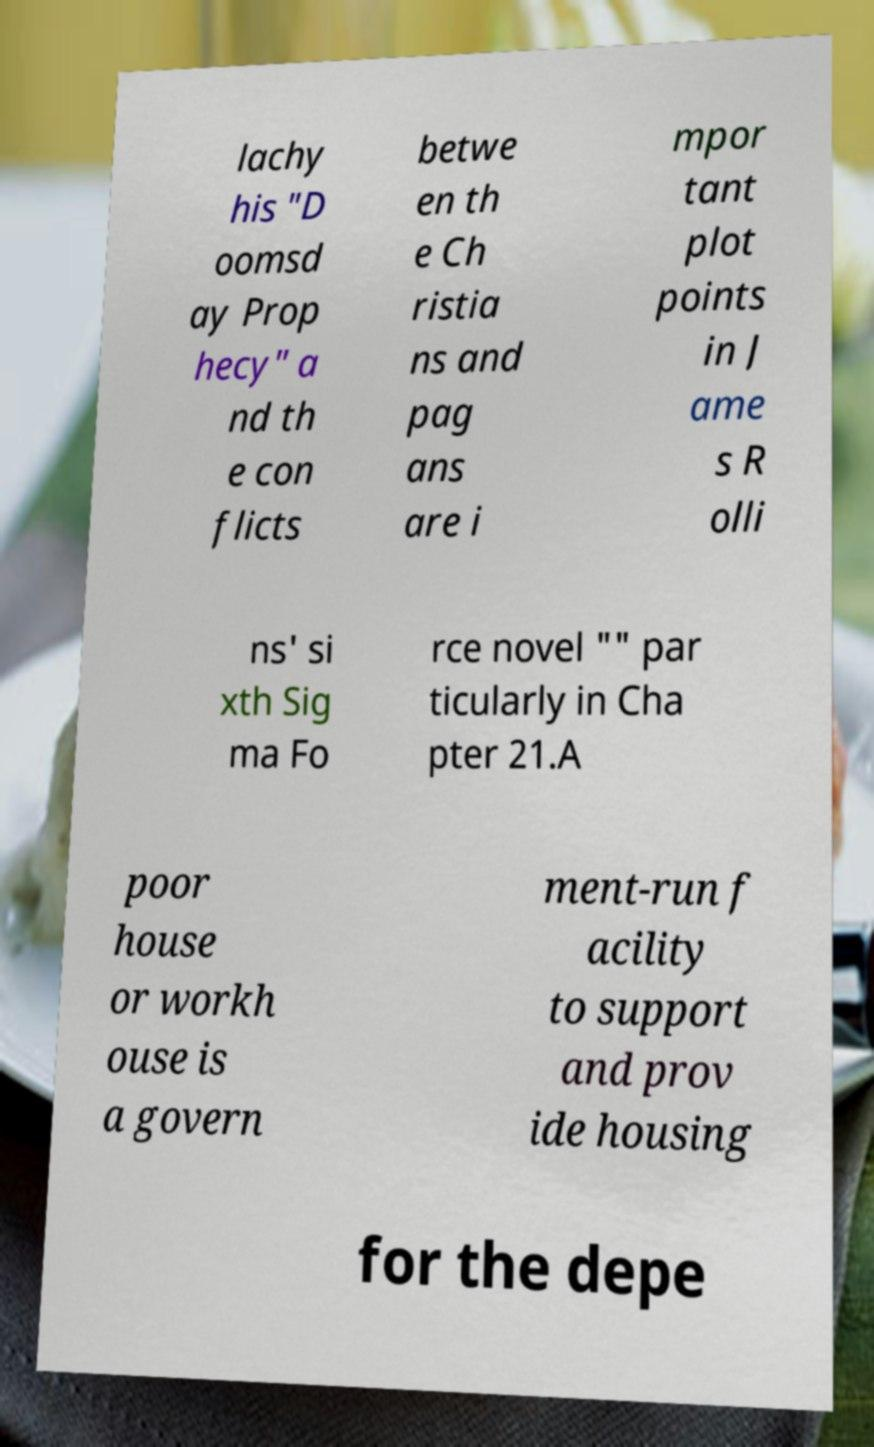Can you read and provide the text displayed in the image?This photo seems to have some interesting text. Can you extract and type it out for me? lachy his "D oomsd ay Prop hecy" a nd th e con flicts betwe en th e Ch ristia ns and pag ans are i mpor tant plot points in J ame s R olli ns' si xth Sig ma Fo rce novel "" par ticularly in Cha pter 21.A poor house or workh ouse is a govern ment-run f acility to support and prov ide housing for the depe 